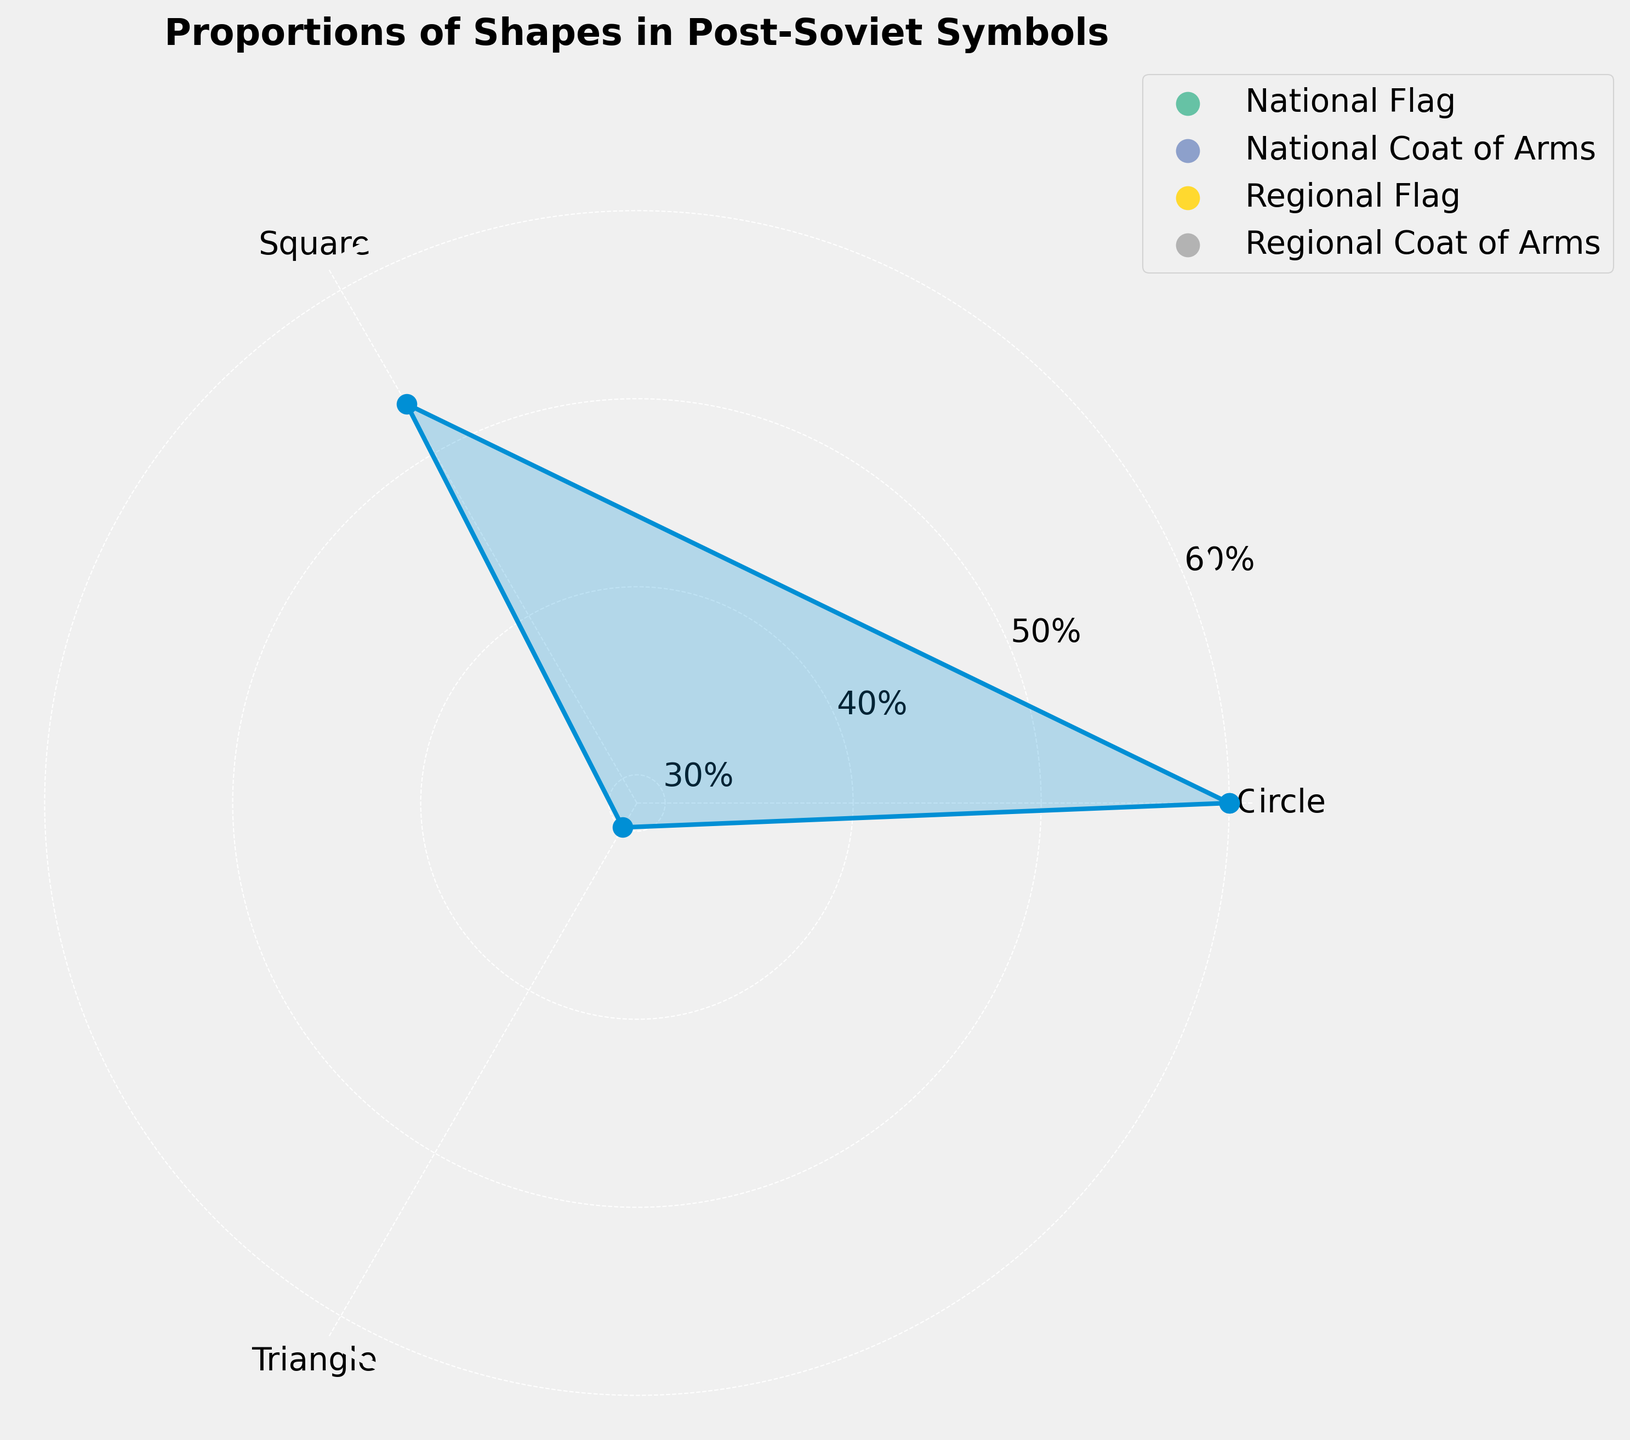What is the title of the figure? The title of the figure is usually positioned at the top and is clearly readable. Look at the topmost part of the figure for the heading.
Answer: Proportions of Shapes in Post-Soviet Symbols How many shapes are represented in the chart? Count the number of distinct labels on the angles of the rose chart. Each label corresponds to a shape.
Answer: 3 Which shape has the highest total percentage? Find the label (shape) with the longest radial line on the chart. This shape will have the largest area filled.
Answer: Circle What is the total percentage for squares? Look for the radial line labeled "Square" and check its value on the grid lines. Sum up the percentages of all entities representing squares if necessary.
Answer: 53% How many entity types are represented in the legend? Count the distinct labels in the legend box usually positioned outside the main plot area.
Answer: 4 What is the second most common shape? Compare the lengths of the radial lines for each shape and identify the one with the second-largest total percentage.
Answer: Square Which entity type is associated with the smallest shape percentage? Look at the legend to match each shape with its entity type and find the smallest percentage shown on the chart.
Answer: Regional Flag How much greater is the circle's percentage compared to triangles? Find the percentage values of circles and triangles, then calculate the difference. For circles, sum all the percentages linked to circles, similarly for triangles.
Answer: 20% What is the difference between the highest and lowest percentages displayed? Identify the highest and lowest percentage values shown on any radial line and calculate the difference.
Answer: 25% Which shape is most commonly used in national flags? Look at the labels of shapes and their corresponding radial lines specifically tagged as "National Flag" in the legend, then determine which shape has the highest cumulative percentage.
Answer: Circle 